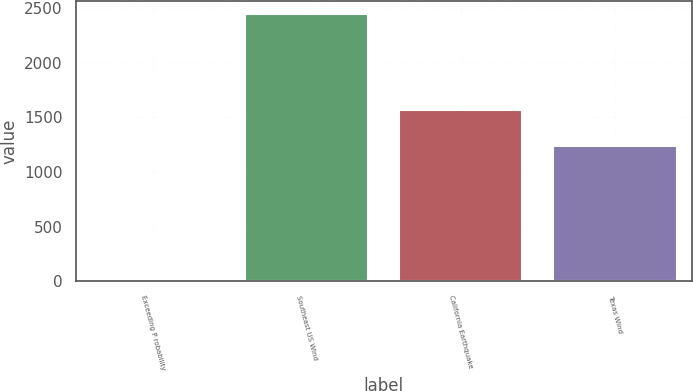<chart> <loc_0><loc_0><loc_500><loc_500><bar_chart><fcel>Exceeding P robability<fcel>Southeast US Wind<fcel>California Earthquake<fcel>Texas Wind<nl><fcel>0.1<fcel>2444<fcel>1571<fcel>1236<nl></chart> 